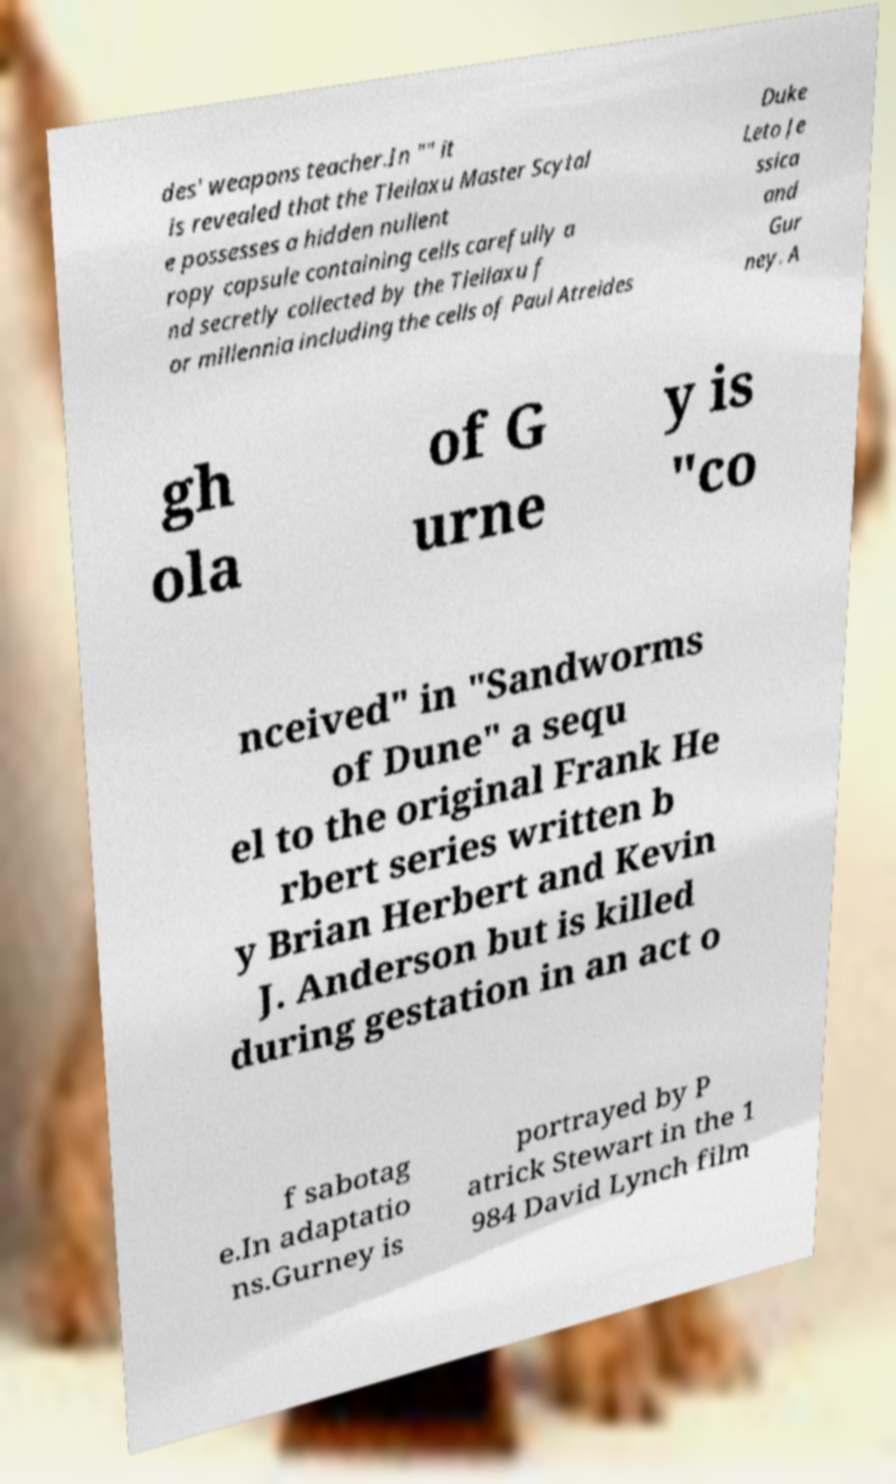Could you extract and type out the text from this image? des' weapons teacher.In "" it is revealed that the Tleilaxu Master Scytal e possesses a hidden nullent ropy capsule containing cells carefully a nd secretly collected by the Tleilaxu f or millennia including the cells of Paul Atreides Duke Leto Je ssica and Gur ney. A gh ola of G urne y is "co nceived" in "Sandworms of Dune" a sequ el to the original Frank He rbert series written b y Brian Herbert and Kevin J. Anderson but is killed during gestation in an act o f sabotag e.In adaptatio ns.Gurney is portrayed by P atrick Stewart in the 1 984 David Lynch film 